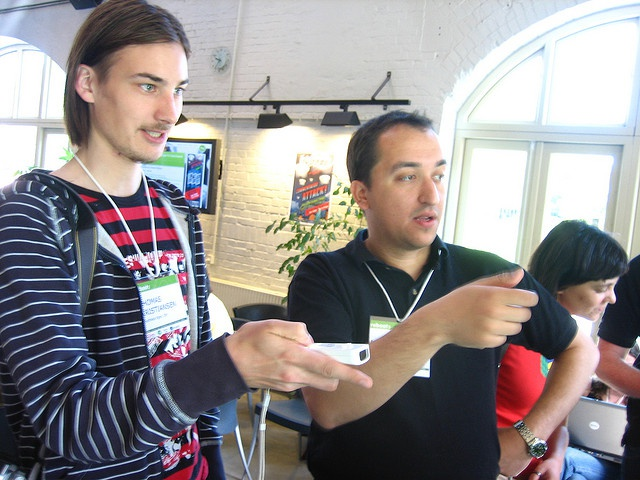Describe the objects in this image and their specific colors. I can see people in lavender, black, navy, gray, and tan tones, people in lavender, black, tan, and gray tones, people in lavender, black, gray, tan, and maroon tones, people in lavender, black, brown, and navy tones, and tv in lavender, lightblue, and gray tones in this image. 